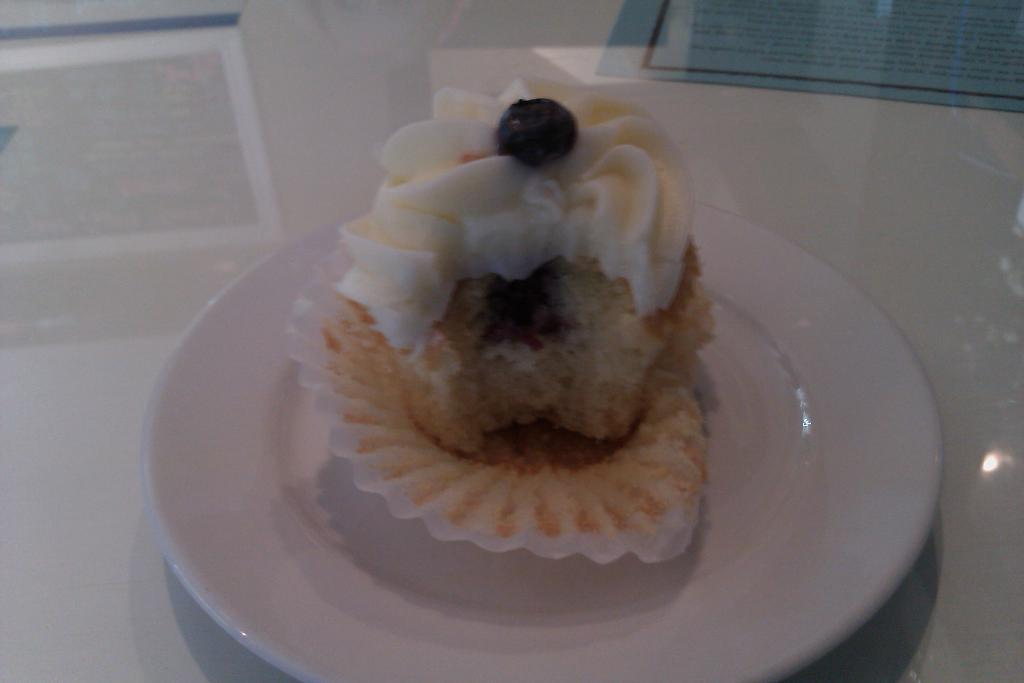What is on the plate that is visible in the image? There is food on a plate in the image. What color is the plate? The plate is white. Where is the plate located in the image? The plate is on a white surface. What color is the paper visible in the background? There is a blue paper visible in the background. Can you see any fairies dancing around the plate in the image? There are no fairies present in the image. How many elbows can be seen on the plate in the image? The image does not show any elbows; it only shows a plate of food. 